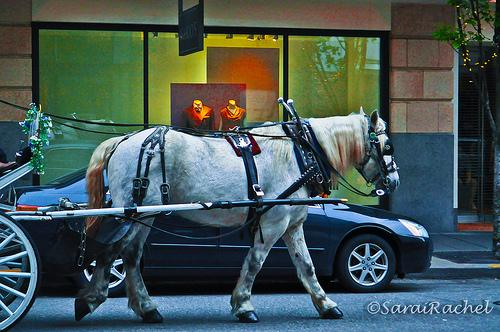Identify the color, state, and position of the vehicle adjacent to the horse. There is a shiny, dark, black car parked by the curb next to the white and brown horse and carriage in front of the storefront. Can you provide a detailed observation of the horse's physical features and its equipment? The horse is white and brown with a bushy white and brown tail, black hooves, and a black leather bridle. It's wearing a girth under its belly, black reins, and a harness with a long tug. Examine the image for any peculiarities or unusual elements. A striking oddity in the image is the painting of two headless persons in red clothing seen near the mannequins inside the store. What is the primary focus of this image and its activity? A white horse with a brown tail and mane is walking on the street, pulling a carriage which has blue flowers on it. Describe the exterior appearance of the building and store in the image. The storefront features a glass window and a stone front with a brick section, while the store inside has green walls, and a sign on the roof. Analyze the interactions between objects in the image and describe any notable relationships.  The horse is pulling a carriage with a long tug, and it's wearing a bridle, girth, and harness for connection and control; the car is parked near the horse and carriage, both positioned in front of the storefront. How many mannequins are in the store, and what is their appearance? There are two mannequins inside the store, and one of them appears to have a painting depicting two headless persons in red. Enumerate different types of wheels present in the image, their position, and color. There are four wheels: The front and rear wheels of a vehicle in black and white, a round wheel of a car, and the wheel of a cart, all located around the horse and carriage. Provide a brief description of the scene depicted in the photograph. A horse and carriage are on the street, with a black car parked next to them in front of a storefront that has mannequins and a green wall inside. What type of decoration or lighting is visible in the image? There are Christmas lights in a tree and blue flowers on the carriage as decorative elements in the image. 